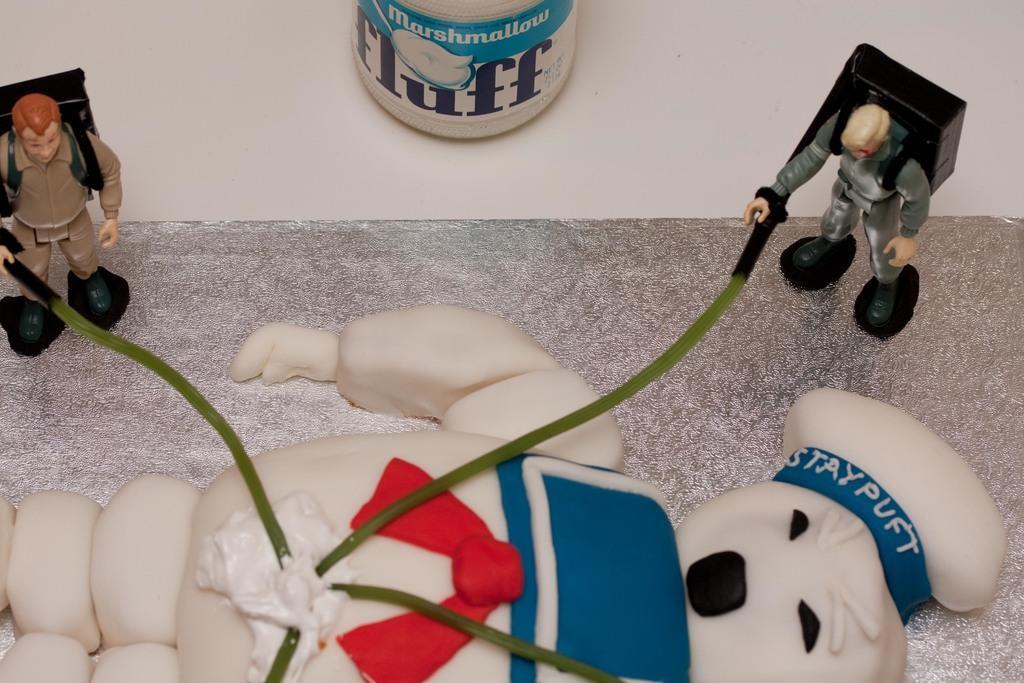Please provide a concise description of this image. In this picture I can see there is a doll and few other small dolls here and there are cables connected to the doll and it is placed on a silver surface. 